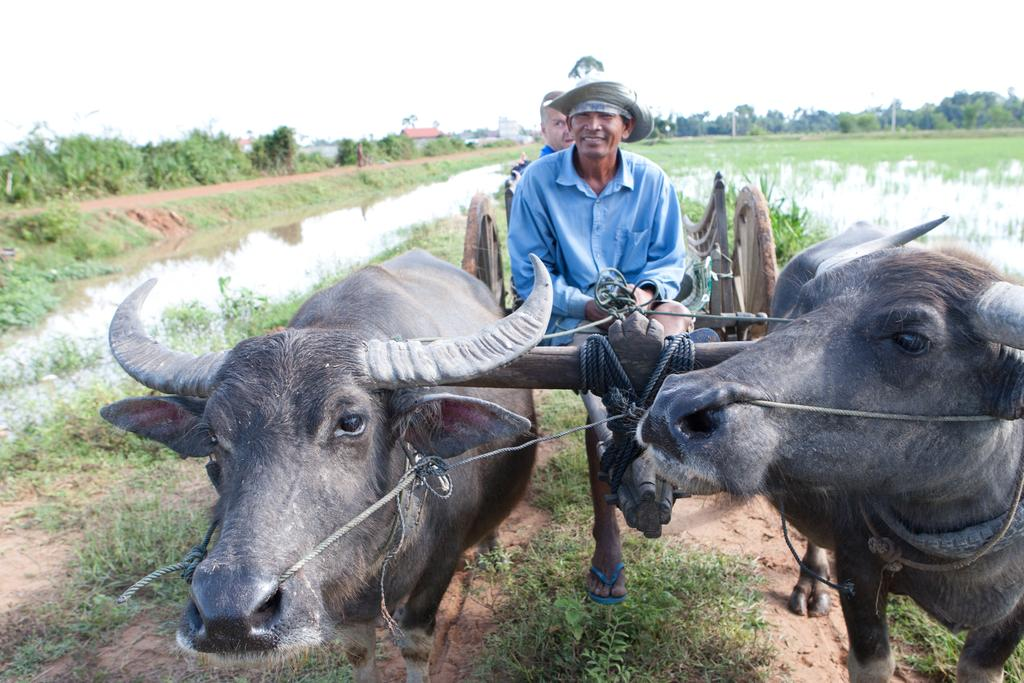How many animals are in the image? There are two animals in the image. How many men are in the image? There are two men in the image. What are the men and animals doing in the image? The men and animals are sitting in a cart. What can be seen in the background of the image? Water, trees, and poles are visible in the background of the image. What type of corn can be seen growing near the cart in the image? There is no corn visible in the image; it only shows water, trees, and poles in the background. Can you tell me the date on the calendar in the image? There is no calendar present in the image. 